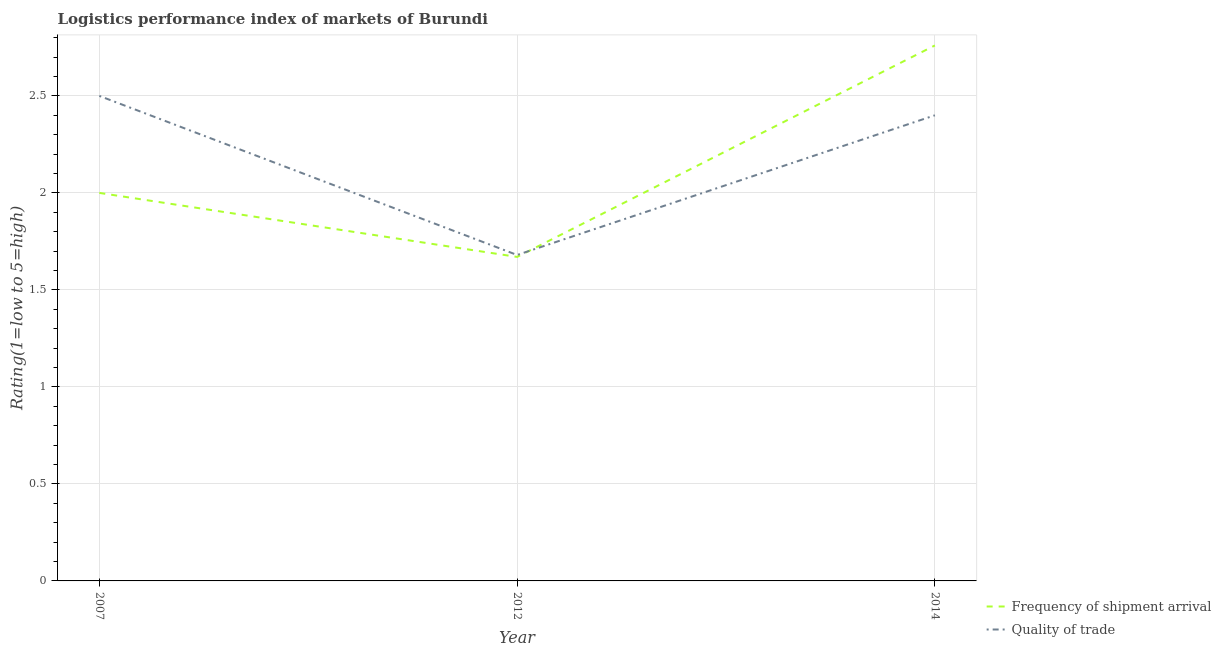Is the number of lines equal to the number of legend labels?
Your answer should be compact. Yes. What is the lpi of frequency of shipment arrival in 2012?
Offer a terse response. 1.67. Across all years, what is the maximum lpi of frequency of shipment arrival?
Make the answer very short. 2.76. Across all years, what is the minimum lpi quality of trade?
Keep it short and to the point. 1.68. In which year was the lpi quality of trade minimum?
Your response must be concise. 2012. What is the total lpi quality of trade in the graph?
Your answer should be compact. 6.58. What is the difference between the lpi of frequency of shipment arrival in 2007 and that in 2014?
Your answer should be very brief. -0.76. What is the difference between the lpi quality of trade in 2012 and the lpi of frequency of shipment arrival in 2007?
Provide a short and direct response. -0.32. What is the average lpi of frequency of shipment arrival per year?
Your answer should be very brief. 2.14. In the year 2012, what is the difference between the lpi of frequency of shipment arrival and lpi quality of trade?
Your answer should be very brief. -0.01. In how many years, is the lpi quality of trade greater than 0.8?
Make the answer very short. 3. What is the ratio of the lpi quality of trade in 2007 to that in 2012?
Make the answer very short. 1.49. Is the lpi of frequency of shipment arrival in 2007 less than that in 2012?
Your answer should be very brief. No. Is the difference between the lpi quality of trade in 2007 and 2014 greater than the difference between the lpi of frequency of shipment arrival in 2007 and 2014?
Provide a succinct answer. Yes. What is the difference between the highest and the second highest lpi quality of trade?
Your answer should be very brief. 0.1. What is the difference between the highest and the lowest lpi quality of trade?
Give a very brief answer. 0.82. Is the sum of the lpi of frequency of shipment arrival in 2007 and 2012 greater than the maximum lpi quality of trade across all years?
Give a very brief answer. Yes. Is the lpi of frequency of shipment arrival strictly less than the lpi quality of trade over the years?
Give a very brief answer. No. Are the values on the major ticks of Y-axis written in scientific E-notation?
Provide a succinct answer. No. Does the graph contain any zero values?
Offer a terse response. No. Does the graph contain grids?
Provide a short and direct response. Yes. Where does the legend appear in the graph?
Keep it short and to the point. Bottom right. What is the title of the graph?
Offer a terse response. Logistics performance index of markets of Burundi. Does "Grants" appear as one of the legend labels in the graph?
Provide a succinct answer. No. What is the label or title of the Y-axis?
Your answer should be compact. Rating(1=low to 5=high). What is the Rating(1=low to 5=high) of Frequency of shipment arrival in 2012?
Keep it short and to the point. 1.67. What is the Rating(1=low to 5=high) in Quality of trade in 2012?
Ensure brevity in your answer.  1.68. What is the Rating(1=low to 5=high) of Frequency of shipment arrival in 2014?
Offer a very short reply. 2.76. Across all years, what is the maximum Rating(1=low to 5=high) of Frequency of shipment arrival?
Provide a succinct answer. 2.76. Across all years, what is the minimum Rating(1=low to 5=high) in Frequency of shipment arrival?
Your answer should be very brief. 1.67. Across all years, what is the minimum Rating(1=low to 5=high) of Quality of trade?
Provide a short and direct response. 1.68. What is the total Rating(1=low to 5=high) of Frequency of shipment arrival in the graph?
Your response must be concise. 6.43. What is the total Rating(1=low to 5=high) in Quality of trade in the graph?
Provide a short and direct response. 6.58. What is the difference between the Rating(1=low to 5=high) in Frequency of shipment arrival in 2007 and that in 2012?
Make the answer very short. 0.33. What is the difference between the Rating(1=low to 5=high) in Quality of trade in 2007 and that in 2012?
Keep it short and to the point. 0.82. What is the difference between the Rating(1=low to 5=high) of Frequency of shipment arrival in 2007 and that in 2014?
Ensure brevity in your answer.  -0.76. What is the difference between the Rating(1=low to 5=high) of Quality of trade in 2007 and that in 2014?
Your answer should be compact. 0.1. What is the difference between the Rating(1=low to 5=high) in Frequency of shipment arrival in 2012 and that in 2014?
Give a very brief answer. -1.09. What is the difference between the Rating(1=low to 5=high) of Quality of trade in 2012 and that in 2014?
Offer a very short reply. -0.72. What is the difference between the Rating(1=low to 5=high) of Frequency of shipment arrival in 2007 and the Rating(1=low to 5=high) of Quality of trade in 2012?
Offer a terse response. 0.32. What is the difference between the Rating(1=low to 5=high) of Frequency of shipment arrival in 2007 and the Rating(1=low to 5=high) of Quality of trade in 2014?
Offer a terse response. -0.4. What is the difference between the Rating(1=low to 5=high) of Frequency of shipment arrival in 2012 and the Rating(1=low to 5=high) of Quality of trade in 2014?
Offer a very short reply. -0.73. What is the average Rating(1=low to 5=high) in Frequency of shipment arrival per year?
Offer a terse response. 2.14. What is the average Rating(1=low to 5=high) of Quality of trade per year?
Make the answer very short. 2.19. In the year 2007, what is the difference between the Rating(1=low to 5=high) in Frequency of shipment arrival and Rating(1=low to 5=high) in Quality of trade?
Give a very brief answer. -0.5. In the year 2012, what is the difference between the Rating(1=low to 5=high) in Frequency of shipment arrival and Rating(1=low to 5=high) in Quality of trade?
Your answer should be very brief. -0.01. In the year 2014, what is the difference between the Rating(1=low to 5=high) of Frequency of shipment arrival and Rating(1=low to 5=high) of Quality of trade?
Keep it short and to the point. 0.36. What is the ratio of the Rating(1=low to 5=high) in Frequency of shipment arrival in 2007 to that in 2012?
Your response must be concise. 1.2. What is the ratio of the Rating(1=low to 5=high) in Quality of trade in 2007 to that in 2012?
Ensure brevity in your answer.  1.49. What is the ratio of the Rating(1=low to 5=high) of Frequency of shipment arrival in 2007 to that in 2014?
Provide a short and direct response. 0.72. What is the ratio of the Rating(1=low to 5=high) of Quality of trade in 2007 to that in 2014?
Give a very brief answer. 1.04. What is the ratio of the Rating(1=low to 5=high) in Frequency of shipment arrival in 2012 to that in 2014?
Keep it short and to the point. 0.61. What is the difference between the highest and the second highest Rating(1=low to 5=high) in Frequency of shipment arrival?
Make the answer very short. 0.76. What is the difference between the highest and the second highest Rating(1=low to 5=high) of Quality of trade?
Provide a succinct answer. 0.1. What is the difference between the highest and the lowest Rating(1=low to 5=high) of Frequency of shipment arrival?
Your answer should be compact. 1.09. What is the difference between the highest and the lowest Rating(1=low to 5=high) of Quality of trade?
Ensure brevity in your answer.  0.82. 